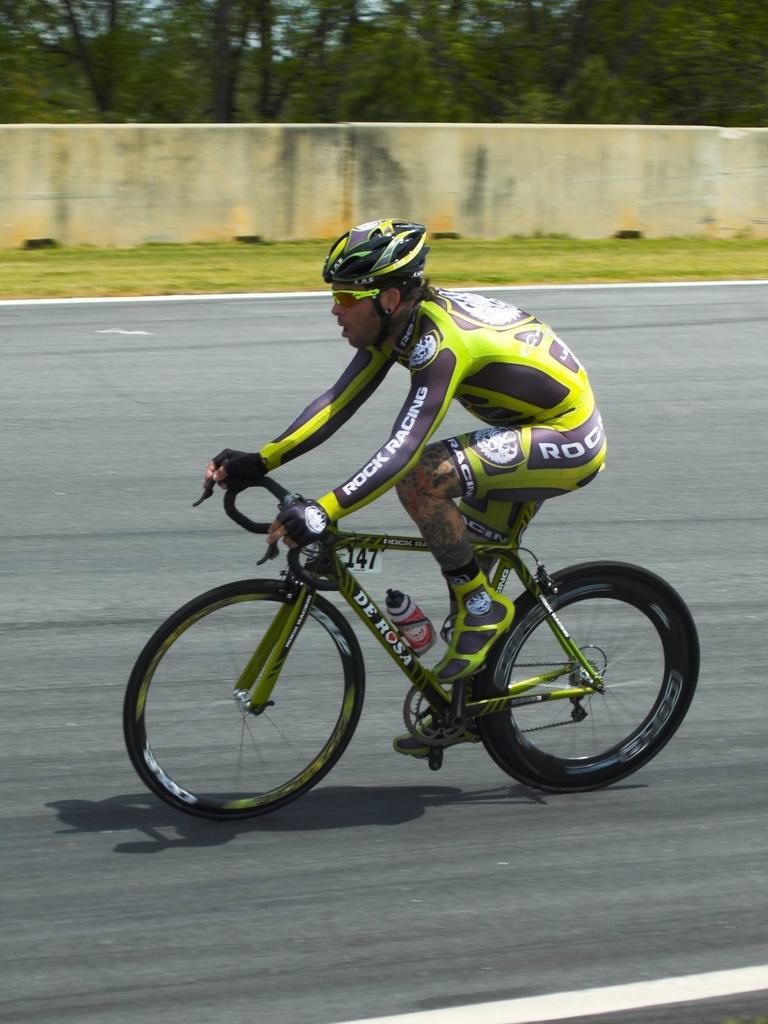Please provide a concise description of this image. In the image in the center we can see one person riding cycle on the road and he is wearing a helmet. In the background we can see trees,grass and wall. 